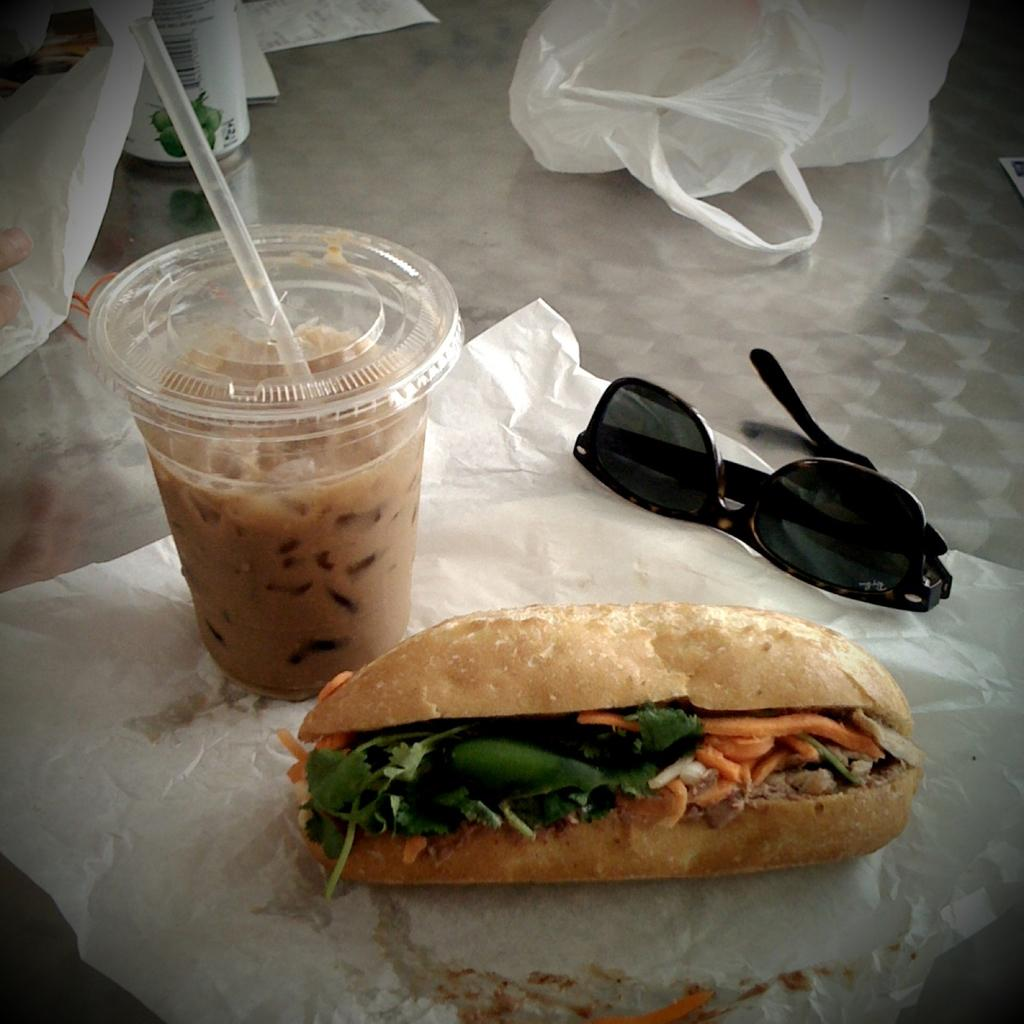What is in the glass on the left side of the image? There is a drink in a glass on the left side of the image. What type of food is on the tissue paper in the image? There is a burger on a tissue paper in the image. What can be seen on the right side of the image? There are glasses on the right side of the image. Can you tell me how many celery stalks are in the pail in the image? There is no pail or celery present in the image. What type of tools does the carpenter have in the image? There is no carpenter or tools present in the image. 